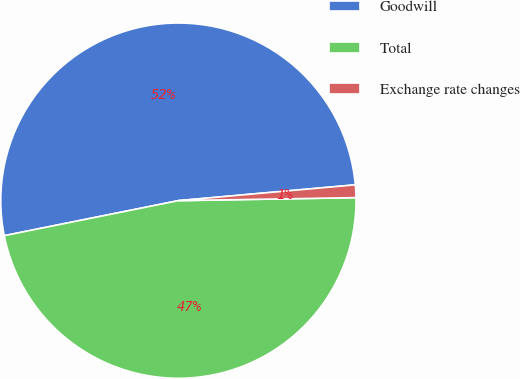Convert chart. <chart><loc_0><loc_0><loc_500><loc_500><pie_chart><fcel>Goodwill<fcel>Total<fcel>Exchange rate changes<nl><fcel>51.74%<fcel>47.11%<fcel>1.15%<nl></chart> 